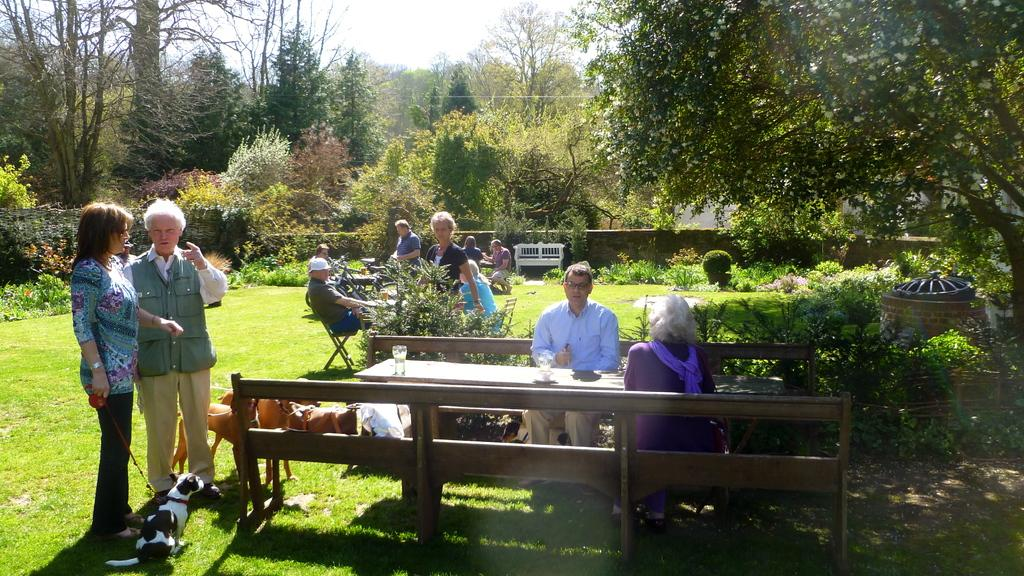What are the people in the image doing? The people in the image are sitting in groups. Where are the people sitting? The people are sitting at different tables. What is the location of the scene in the image? The setting is in a garden. What can be seen in the garden besides the people? There are trees in the garden. Are there any animals present in the garden? Yes, dogs are present in the garden. What type of horn can be heard in the image? There is no horn present or audible in the image. 